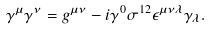Convert formula to latex. <formula><loc_0><loc_0><loc_500><loc_500>\gamma ^ { \mu } \gamma ^ { \nu } = g ^ { \mu \nu } - i \gamma ^ { 0 } \sigma ^ { 1 2 } \epsilon ^ { \mu \nu \lambda } \gamma _ { \lambda } .</formula> 